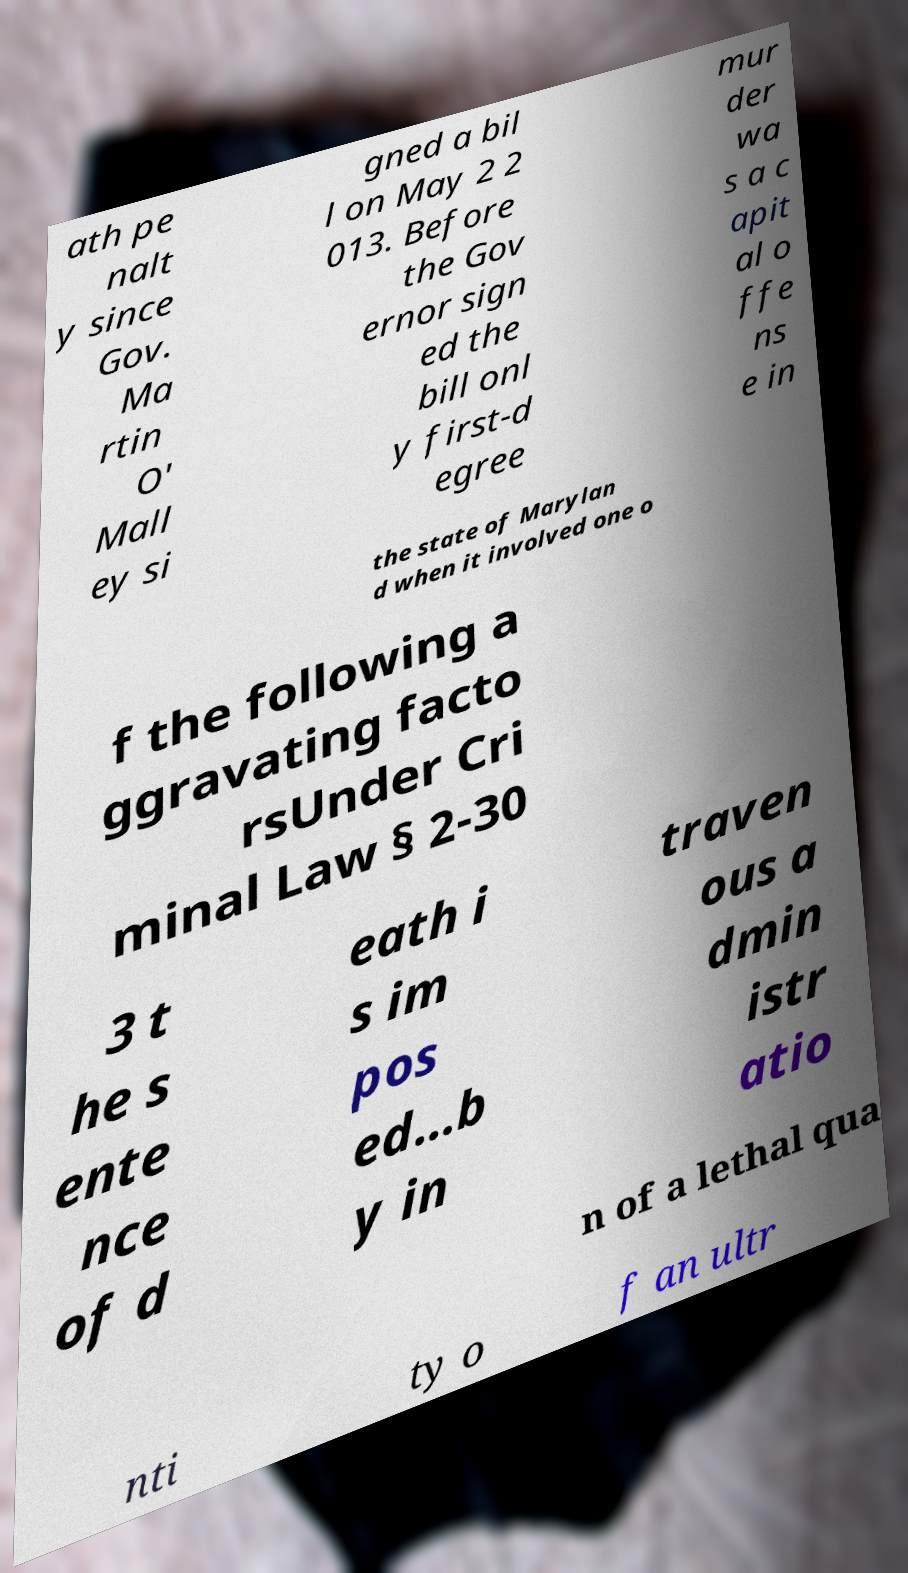Could you assist in decoding the text presented in this image and type it out clearly? ath pe nalt y since Gov. Ma rtin O' Mall ey si gned a bil l on May 2 2 013. Before the Gov ernor sign ed the bill onl y first-d egree mur der wa s a c apit al o ffe ns e in the state of Marylan d when it involved one o f the following a ggravating facto rsUnder Cri minal Law § 2-30 3 t he s ente nce of d eath i s im pos ed…b y in traven ous a dmin istr atio n of a lethal qua nti ty o f an ultr 